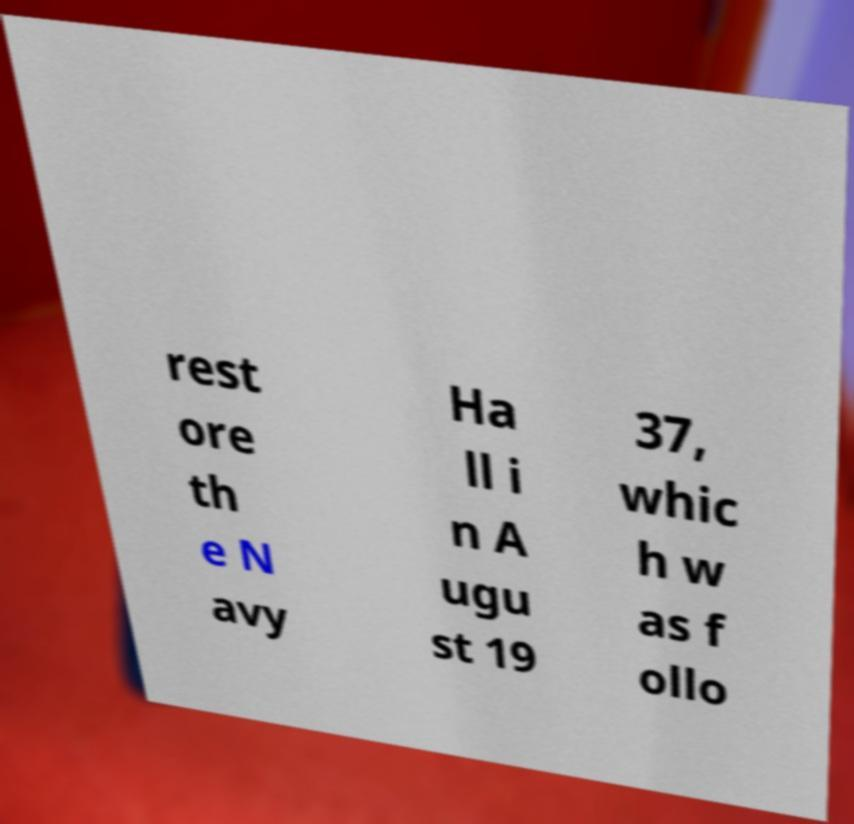What messages or text are displayed in this image? I need them in a readable, typed format. rest ore th e N avy Ha ll i n A ugu st 19 37, whic h w as f ollo 